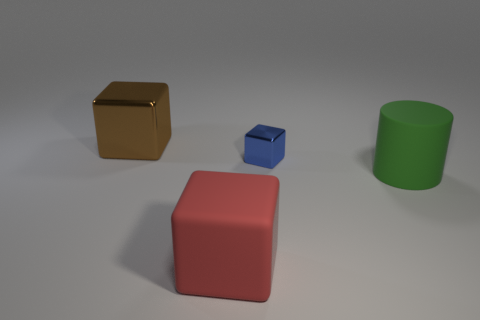Subtract all small blue metal cubes. How many cubes are left? 2 Add 3 big objects. How many objects exist? 7 Subtract all small green spheres. Subtract all cylinders. How many objects are left? 3 Add 2 tiny blue cubes. How many tiny blue cubes are left? 3 Add 3 spheres. How many spheres exist? 3 Subtract 0 cyan balls. How many objects are left? 4 Subtract all cylinders. How many objects are left? 3 